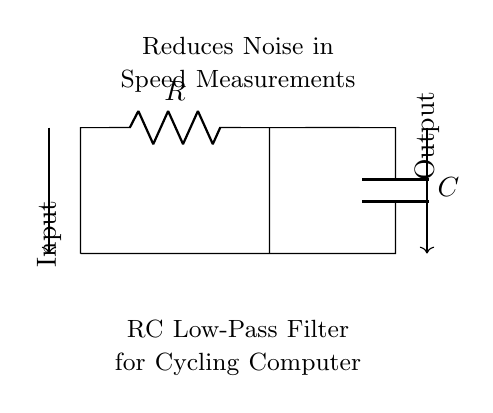What type of filter is represented in the circuit? The circuit diagram indicates a low-pass filter as it only allows low-frequency signals to pass while attenuating high-frequency signals. This information is derived from the components included (a resistor and capacitor) and their configuration.
Answer: low-pass filter What are the components used in the circuit? The circuit consists of a resistor and a capacitor, clearly labeled in the diagram. The resistor is represented by R, and the capacitor is represented by C. Identifying these components is straightforward from their symbols in the circuit diagram.
Answer: resistor and capacitor What is the purpose of this RC circuit in a cycling computer? The purpose of the circuit is to reduce noise in speed measurements. This is specifically noted in the annotations provided in the circuit diagram. By filtering out high-frequency noise, the circuit ensures more accurate readings.
Answer: reduce noise What is the input to this circuit? The input to the circuit is labeled clearly on the left side of the diagram, indicating where the signal enters the circuit. This corresponds to the point before the resistor.
Answer: Input Where is the output of the circuit located? The output of the circuit is positioned on the right side, where the signal is taken after the capacitor. This is the point where the filtered signal exits the circuit, indicating its endpoint visibly on the diagram.
Answer: Output What effect does increasing the resistance have on the cutoff frequency? Increasing the resistance will lower the cutoff frequency of the filter, meaning the circuit will allow fewer high frequencies to pass. This is due to the relationship between resistance and the time constant of the circuit, which determines the frequency response.
Answer: lower cutoff frequency What kind of analysis can be performed to determine the noise reduction efficiency? To assess the noise reduction efficiency, one can perform a frequency response analysis or a Bode plot of the circuit. By analyzing how the circuit responds to various frequencies, one can determine how effective the filter is at reducing noise.
Answer: frequency response analysis 